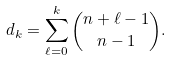<formula> <loc_0><loc_0><loc_500><loc_500>d _ { k } = \sum _ { \ell = 0 } ^ { k } \binom { n + \ell - 1 } { n - 1 } .</formula> 